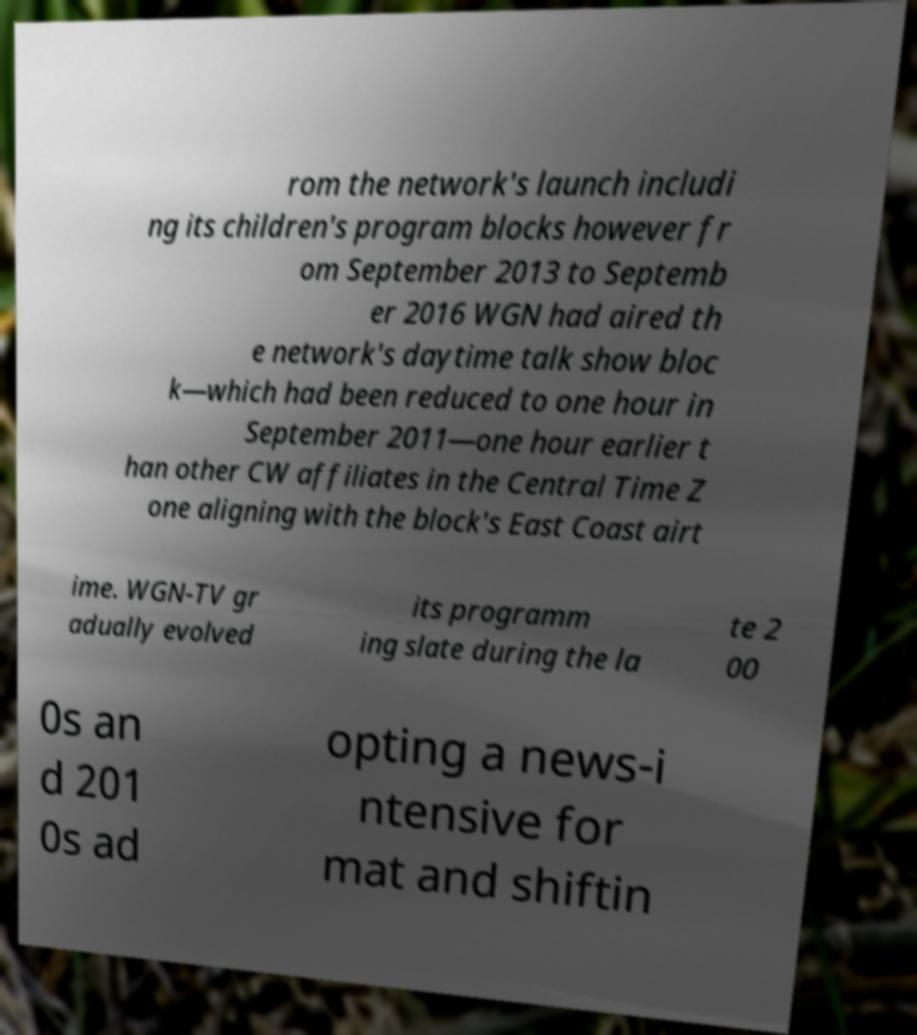Please identify and transcribe the text found in this image. rom the network's launch includi ng its children's program blocks however fr om September 2013 to Septemb er 2016 WGN had aired th e network's daytime talk show bloc k—which had been reduced to one hour in September 2011—one hour earlier t han other CW affiliates in the Central Time Z one aligning with the block's East Coast airt ime. WGN-TV gr adually evolved its programm ing slate during the la te 2 00 0s an d 201 0s ad opting a news-i ntensive for mat and shiftin 